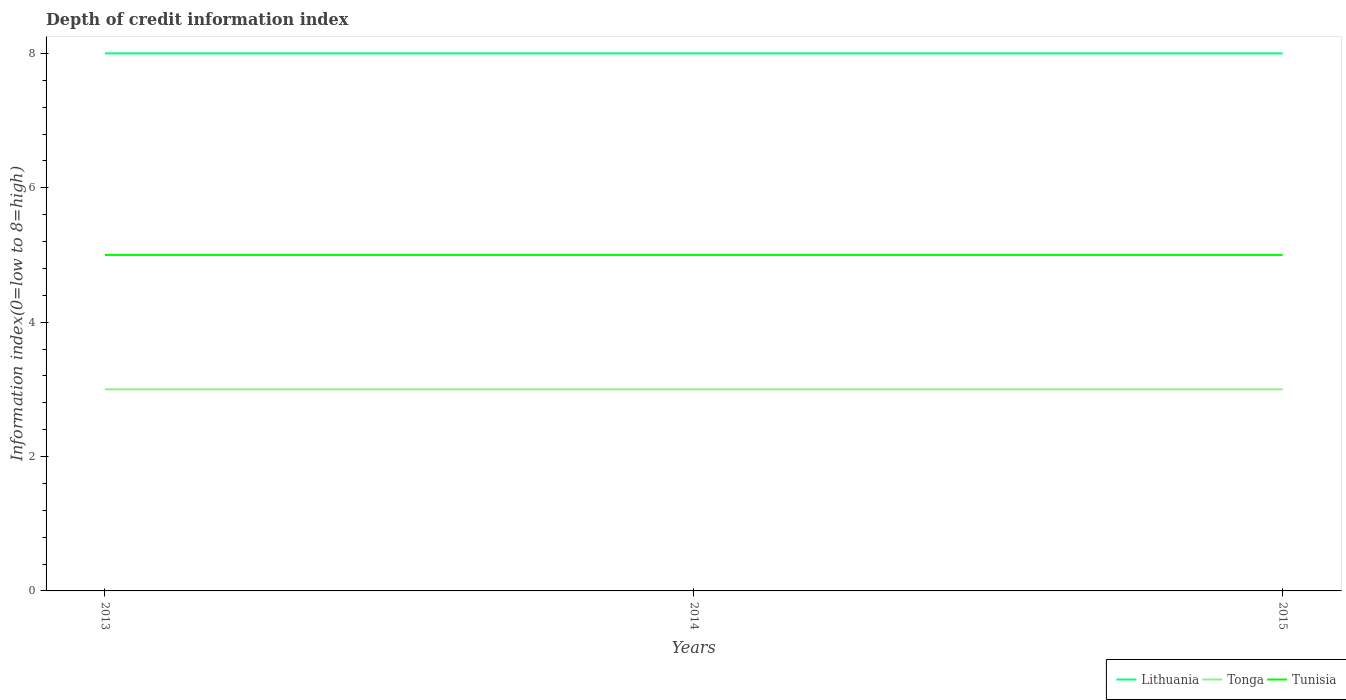Is the number of lines equal to the number of legend labels?
Your answer should be very brief. Yes. Across all years, what is the maximum information index in Tunisia?
Offer a very short reply. 5. What is the total information index in Lithuania in the graph?
Your answer should be compact. 0. What is the difference between the highest and the second highest information index in Tonga?
Offer a very short reply. 0. What is the difference between the highest and the lowest information index in Tonga?
Ensure brevity in your answer.  0. Is the information index in Tonga strictly greater than the information index in Tunisia over the years?
Offer a terse response. Yes. How many lines are there?
Offer a terse response. 3. What is the difference between two consecutive major ticks on the Y-axis?
Your answer should be compact. 2. Are the values on the major ticks of Y-axis written in scientific E-notation?
Offer a very short reply. No. Does the graph contain any zero values?
Your answer should be very brief. No. Where does the legend appear in the graph?
Your answer should be very brief. Bottom right. What is the title of the graph?
Give a very brief answer. Depth of credit information index. What is the label or title of the Y-axis?
Your answer should be very brief. Information index(0=low to 8=high). What is the Information index(0=low to 8=high) of Lithuania in 2014?
Give a very brief answer. 8. What is the Information index(0=low to 8=high) of Tonga in 2014?
Your response must be concise. 3. What is the Information index(0=low to 8=high) of Lithuania in 2015?
Ensure brevity in your answer.  8. What is the Information index(0=low to 8=high) of Tonga in 2015?
Keep it short and to the point. 3. Across all years, what is the maximum Information index(0=low to 8=high) of Lithuania?
Offer a very short reply. 8. Across all years, what is the maximum Information index(0=low to 8=high) in Tonga?
Offer a very short reply. 3. Across all years, what is the minimum Information index(0=low to 8=high) in Tonga?
Make the answer very short. 3. Across all years, what is the minimum Information index(0=low to 8=high) in Tunisia?
Make the answer very short. 5. What is the total Information index(0=low to 8=high) in Lithuania in the graph?
Your answer should be very brief. 24. What is the total Information index(0=low to 8=high) of Tonga in the graph?
Provide a short and direct response. 9. What is the difference between the Information index(0=low to 8=high) in Lithuania in 2013 and that in 2014?
Keep it short and to the point. 0. What is the difference between the Information index(0=low to 8=high) in Tonga in 2013 and that in 2014?
Give a very brief answer. 0. What is the difference between the Information index(0=low to 8=high) of Tunisia in 2013 and that in 2014?
Provide a succinct answer. 0. What is the difference between the Information index(0=low to 8=high) of Tonga in 2014 and that in 2015?
Make the answer very short. 0. What is the difference between the Information index(0=low to 8=high) in Lithuania in 2013 and the Information index(0=low to 8=high) in Tunisia in 2015?
Provide a succinct answer. 3. What is the difference between the Information index(0=low to 8=high) in Tonga in 2013 and the Information index(0=low to 8=high) in Tunisia in 2015?
Offer a terse response. -2. What is the difference between the Information index(0=low to 8=high) in Lithuania in 2014 and the Information index(0=low to 8=high) in Tonga in 2015?
Your response must be concise. 5. What is the difference between the Information index(0=low to 8=high) of Lithuania in 2014 and the Information index(0=low to 8=high) of Tunisia in 2015?
Offer a very short reply. 3. What is the difference between the Information index(0=low to 8=high) of Tonga in 2014 and the Information index(0=low to 8=high) of Tunisia in 2015?
Make the answer very short. -2. What is the average Information index(0=low to 8=high) in Lithuania per year?
Provide a succinct answer. 8. What is the average Information index(0=low to 8=high) of Tonga per year?
Provide a succinct answer. 3. In the year 2014, what is the difference between the Information index(0=low to 8=high) of Lithuania and Information index(0=low to 8=high) of Tonga?
Offer a very short reply. 5. In the year 2014, what is the difference between the Information index(0=low to 8=high) of Lithuania and Information index(0=low to 8=high) of Tunisia?
Ensure brevity in your answer.  3. In the year 2014, what is the difference between the Information index(0=low to 8=high) of Tonga and Information index(0=low to 8=high) of Tunisia?
Ensure brevity in your answer.  -2. In the year 2015, what is the difference between the Information index(0=low to 8=high) in Lithuania and Information index(0=low to 8=high) in Tonga?
Provide a succinct answer. 5. In the year 2015, what is the difference between the Information index(0=low to 8=high) in Lithuania and Information index(0=low to 8=high) in Tunisia?
Offer a terse response. 3. In the year 2015, what is the difference between the Information index(0=low to 8=high) in Tonga and Information index(0=low to 8=high) in Tunisia?
Provide a short and direct response. -2. What is the ratio of the Information index(0=low to 8=high) of Tunisia in 2013 to that in 2014?
Your answer should be compact. 1. What is the ratio of the Information index(0=low to 8=high) of Tonga in 2013 to that in 2015?
Your answer should be compact. 1. What is the ratio of the Information index(0=low to 8=high) in Tunisia in 2013 to that in 2015?
Your answer should be very brief. 1. What is the ratio of the Information index(0=low to 8=high) of Tonga in 2014 to that in 2015?
Ensure brevity in your answer.  1. What is the ratio of the Information index(0=low to 8=high) in Tunisia in 2014 to that in 2015?
Offer a terse response. 1. What is the difference between the highest and the second highest Information index(0=low to 8=high) of Lithuania?
Keep it short and to the point. 0. What is the difference between the highest and the second highest Information index(0=low to 8=high) of Tunisia?
Provide a short and direct response. 0. What is the difference between the highest and the lowest Information index(0=low to 8=high) of Lithuania?
Provide a succinct answer. 0. 